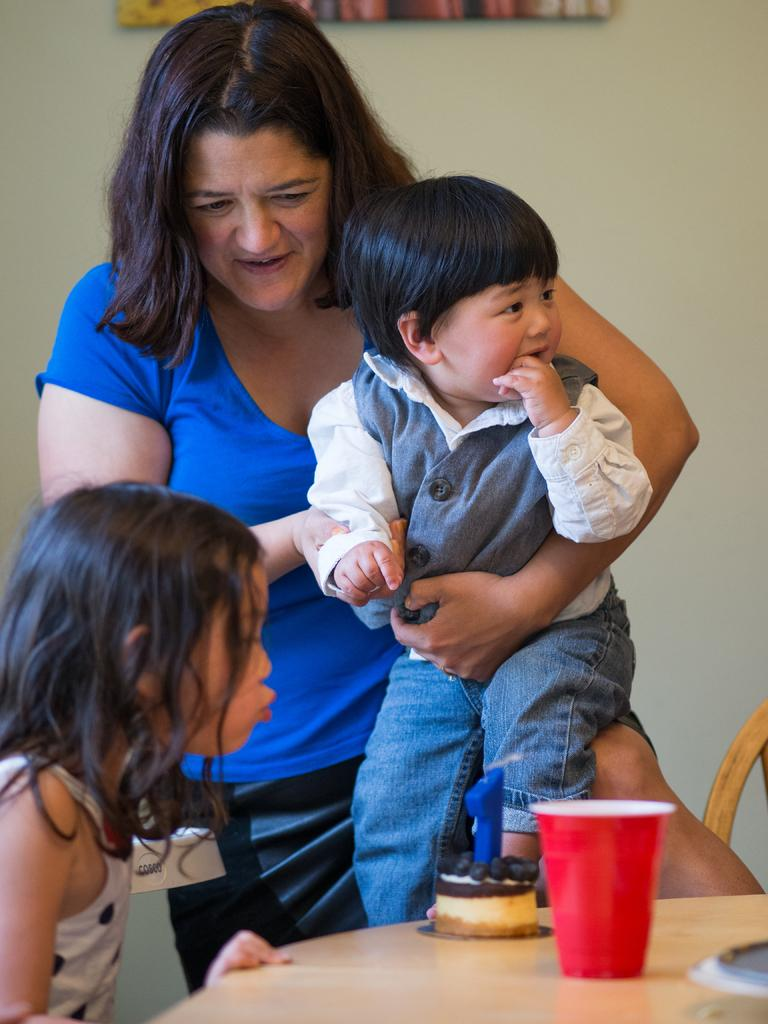Who is the main subject in the image? There is a woman in the image. What is the woman doing in the image? The woman is holding a child. Can you describe the other person in the image? There is a girl in the image. What objects are on the table in the image? There is a cake and a cup on the table. What can be seen in the background of the image? There is a wall in the background of the image. What type of wool is being used to create the window in the image? There is no wool or window present in the image. What form does the cake take in the image? The cake is not described in the image, but it is visible on the table. 